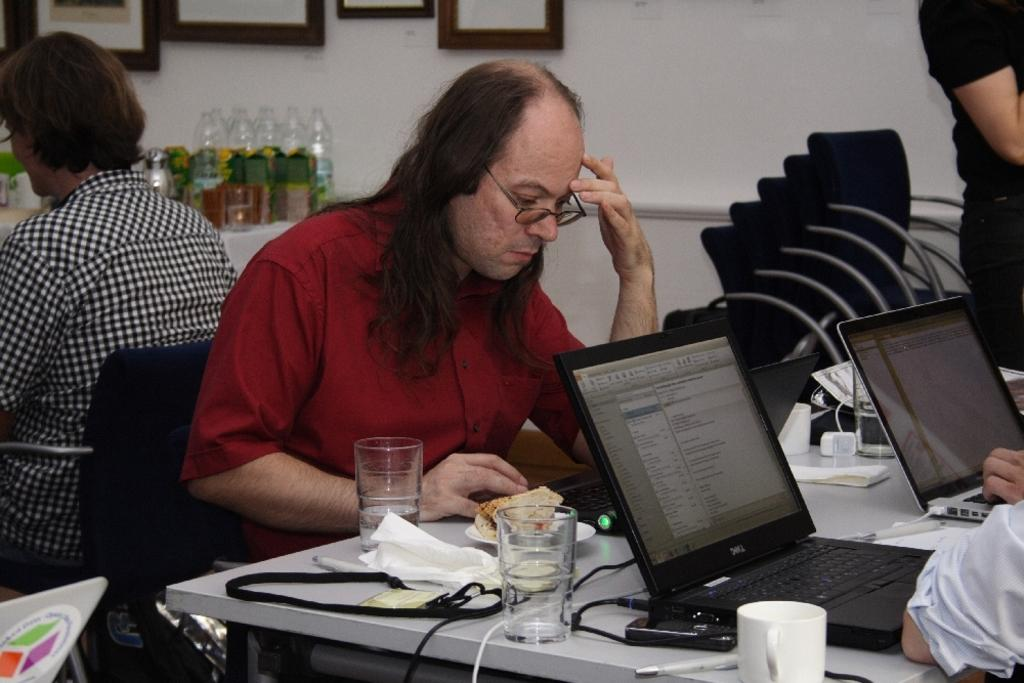What is the guy in the image doing? The guy is sitting on a table in the image. What else can be seen on the table besides the guy? There are food eatables on the table. What electronic devices are present in the image? There are laptops in the image. What can be seen in the background of the image? There are photo frames and glass bottles in the background, as well as empty chairs. What type of scarecrow is standing next to the guy in the image? There is no scarecrow present in the image; it features a guy sitting on a table with food eatables, laptops, photo frames, glass bottles, and empty chairs in the background. How many matches are visible in the image? There are no matches present in the image. 